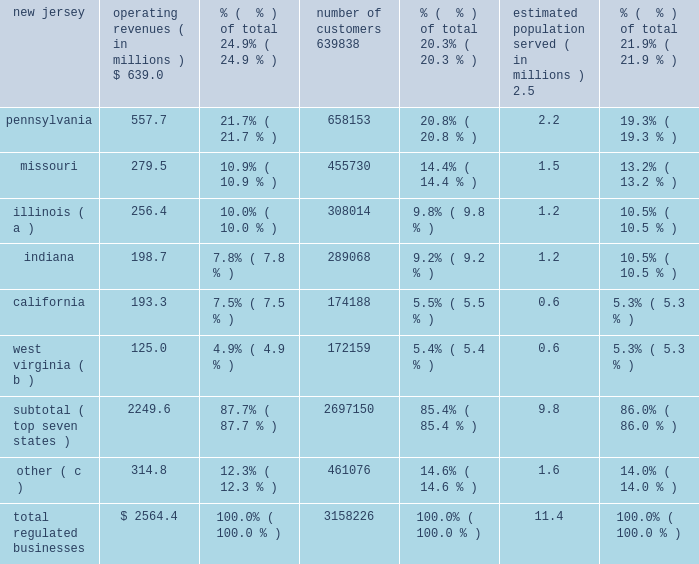As noted above , as a result of these sales , these regulated subsidiaries are presented as discontinued operations for all periods presented .
Therefore , the amounts , statistics and tables presented in this section refer only to on-going operations , unless otherwise noted .
The table sets forth our regulated businesses operating revenue for 2012 and number of customers from continuing operations as well as an estimate of population served as of december 31 , 2012 : operating revenues ( in millions ) % (  % ) of total number of customers % (  % ) of total estimated population served ( in millions ) % (  % ) of total .
( a ) includes illinois-american water company , which we refer to as ilawc and american lake water company , also a regulated subsidiary in illinois .
( b ) west virginia-american water company , which we refer to as wvawc , and its subsidiary bluefield valley water works company .
( c ) includes data from our operating subsidiaries in the following states : georgia , hawaii , iowa , kentucky , maryland , michigan , new york , tennessee , and virginia .
Approximately 87.7% ( 87.7 % ) of operating revenue from our regulated businesses in 2012 was generated from approximately 2.7 million customers in our seven largest states , as measured by operating revenues .
In fiscal year 2012 , no single customer accounted for more than 10% ( 10 % ) of our annual operating revenue .
Overview of networks , facilities and water supply our regulated businesses operate in approximately 1500 communities in 16 states in the united states .
Our primary operating assets include approximately 80 surface water treatment plants , 500 groundwater treatment plants , 1000 groundwater wells , 100 wastewater treatment facilities , 1200 treated water storage facilities , 1300 pumping stations , 90 dams and 46000 miles of mains and collection pipes .
Our regulated utilities own substantially all of the assets used by our regulated businesses .
We generally own the land and physical assets used to store , extract and treat source water .
Typically , we do not own the water itself , which is held in public trust and is allocated to us through contracts and allocation rights granted by federal and state agencies or through the ownership of water rights pursuant to local law .
Maintaining the reliability of our networks is a key activity of our regulated businesses .
We have ongoing infrastructure renewal programs in all states in which our regulated businesses operate .
These programs consist of both rehabilitation of existing mains and replacement of mains that have reached the end of their useful service lives .
Our ability to meet the existing and future water demands of our customers depends on an adequate supply of water .
Drought , governmental restrictions , overuse of sources of water , the protection of threatened species or habitats or other factors may limit the availability of ground and surface water .
We employ a variety of measures to ensure that we have adequate sources of water supply , both in the short-term and over the long-term .
The geographic diversity of our service areas tends to mitigate some of the economic effect of weather extremes we .
What is the approximate customer penetration for the total regulated businesses? 
Rationale: customer penetration - customers divided by total population in those states
Computations: (3158226 * (11.4 * 1000000))
Answer: 36003776400000.0. 